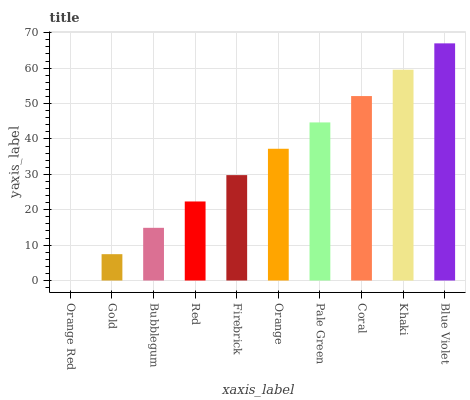Is Orange Red the minimum?
Answer yes or no. Yes. Is Blue Violet the maximum?
Answer yes or no. Yes. Is Gold the minimum?
Answer yes or no. No. Is Gold the maximum?
Answer yes or no. No. Is Gold greater than Orange Red?
Answer yes or no. Yes. Is Orange Red less than Gold?
Answer yes or no. Yes. Is Orange Red greater than Gold?
Answer yes or no. No. Is Gold less than Orange Red?
Answer yes or no. No. Is Orange the high median?
Answer yes or no. Yes. Is Firebrick the low median?
Answer yes or no. Yes. Is Gold the high median?
Answer yes or no. No. Is Khaki the low median?
Answer yes or no. No. 